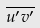Convert formula to latex. <formula><loc_0><loc_0><loc_500><loc_500>\overline { u ^ { \prime } v ^ { \prime } }</formula> 